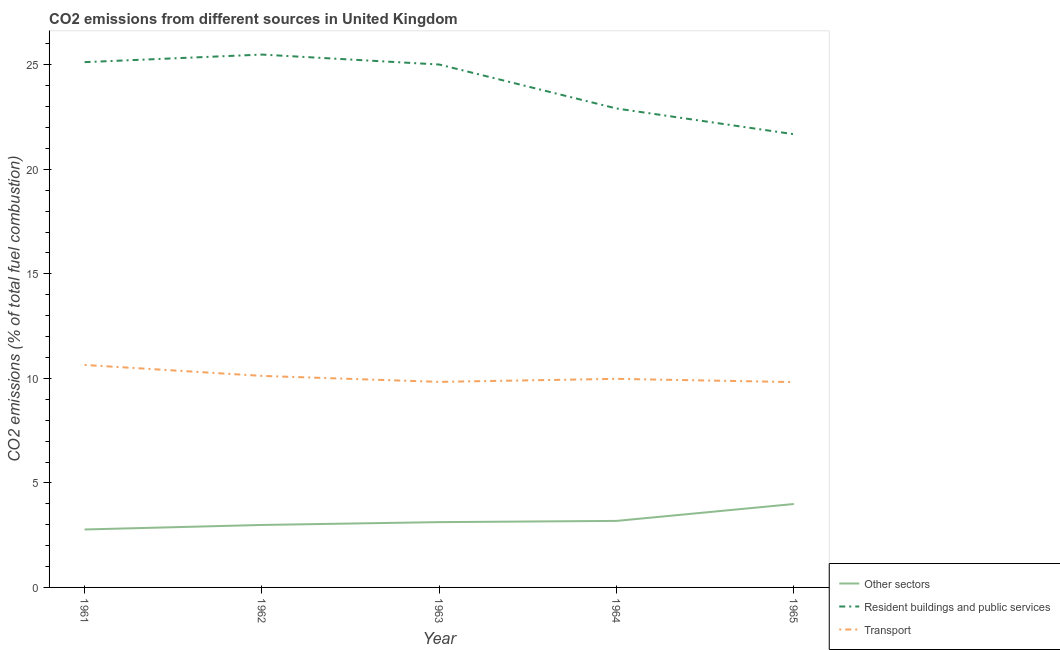How many different coloured lines are there?
Give a very brief answer. 3. Does the line corresponding to percentage of co2 emissions from other sectors intersect with the line corresponding to percentage of co2 emissions from transport?
Your answer should be compact. No. What is the percentage of co2 emissions from transport in 1961?
Make the answer very short. 10.64. Across all years, what is the maximum percentage of co2 emissions from transport?
Provide a short and direct response. 10.64. Across all years, what is the minimum percentage of co2 emissions from resident buildings and public services?
Offer a terse response. 21.68. In which year was the percentage of co2 emissions from other sectors minimum?
Ensure brevity in your answer.  1961. What is the total percentage of co2 emissions from other sectors in the graph?
Offer a very short reply. 16.06. What is the difference between the percentage of co2 emissions from resident buildings and public services in 1962 and that in 1963?
Give a very brief answer. 0.48. What is the difference between the percentage of co2 emissions from resident buildings and public services in 1965 and the percentage of co2 emissions from transport in 1961?
Give a very brief answer. 11.04. What is the average percentage of co2 emissions from transport per year?
Ensure brevity in your answer.  10.08. In the year 1963, what is the difference between the percentage of co2 emissions from other sectors and percentage of co2 emissions from resident buildings and public services?
Your response must be concise. -21.89. What is the ratio of the percentage of co2 emissions from resident buildings and public services in 1964 to that in 1965?
Offer a very short reply. 1.06. Is the difference between the percentage of co2 emissions from other sectors in 1961 and 1963 greater than the difference between the percentage of co2 emissions from transport in 1961 and 1963?
Your answer should be compact. No. What is the difference between the highest and the second highest percentage of co2 emissions from resident buildings and public services?
Your answer should be compact. 0.36. What is the difference between the highest and the lowest percentage of co2 emissions from resident buildings and public services?
Your response must be concise. 3.81. Is the sum of the percentage of co2 emissions from resident buildings and public services in 1961 and 1963 greater than the maximum percentage of co2 emissions from transport across all years?
Make the answer very short. Yes. Is it the case that in every year, the sum of the percentage of co2 emissions from other sectors and percentage of co2 emissions from resident buildings and public services is greater than the percentage of co2 emissions from transport?
Ensure brevity in your answer.  Yes. Is the percentage of co2 emissions from other sectors strictly greater than the percentage of co2 emissions from transport over the years?
Keep it short and to the point. No. Is the percentage of co2 emissions from other sectors strictly less than the percentage of co2 emissions from resident buildings and public services over the years?
Your answer should be compact. Yes. How many years are there in the graph?
Your answer should be very brief. 5. What is the difference between two consecutive major ticks on the Y-axis?
Offer a terse response. 5. Are the values on the major ticks of Y-axis written in scientific E-notation?
Offer a terse response. No. What is the title of the graph?
Ensure brevity in your answer.  CO2 emissions from different sources in United Kingdom. What is the label or title of the Y-axis?
Provide a succinct answer. CO2 emissions (% of total fuel combustion). What is the CO2 emissions (% of total fuel combustion) of Other sectors in 1961?
Keep it short and to the point. 2.77. What is the CO2 emissions (% of total fuel combustion) in Resident buildings and public services in 1961?
Give a very brief answer. 25.13. What is the CO2 emissions (% of total fuel combustion) of Transport in 1961?
Your response must be concise. 10.64. What is the CO2 emissions (% of total fuel combustion) in Other sectors in 1962?
Offer a terse response. 2.99. What is the CO2 emissions (% of total fuel combustion) in Resident buildings and public services in 1962?
Provide a succinct answer. 25.49. What is the CO2 emissions (% of total fuel combustion) of Transport in 1962?
Provide a succinct answer. 10.12. What is the CO2 emissions (% of total fuel combustion) in Other sectors in 1963?
Your answer should be very brief. 3.12. What is the CO2 emissions (% of total fuel combustion) of Resident buildings and public services in 1963?
Offer a terse response. 25.01. What is the CO2 emissions (% of total fuel combustion) in Transport in 1963?
Provide a succinct answer. 9.83. What is the CO2 emissions (% of total fuel combustion) of Other sectors in 1964?
Give a very brief answer. 3.18. What is the CO2 emissions (% of total fuel combustion) of Resident buildings and public services in 1964?
Your response must be concise. 22.91. What is the CO2 emissions (% of total fuel combustion) of Transport in 1964?
Give a very brief answer. 9.98. What is the CO2 emissions (% of total fuel combustion) in Other sectors in 1965?
Make the answer very short. 3.99. What is the CO2 emissions (% of total fuel combustion) in Resident buildings and public services in 1965?
Make the answer very short. 21.68. What is the CO2 emissions (% of total fuel combustion) of Transport in 1965?
Give a very brief answer. 9.82. Across all years, what is the maximum CO2 emissions (% of total fuel combustion) in Other sectors?
Offer a terse response. 3.99. Across all years, what is the maximum CO2 emissions (% of total fuel combustion) in Resident buildings and public services?
Ensure brevity in your answer.  25.49. Across all years, what is the maximum CO2 emissions (% of total fuel combustion) in Transport?
Provide a succinct answer. 10.64. Across all years, what is the minimum CO2 emissions (% of total fuel combustion) of Other sectors?
Keep it short and to the point. 2.77. Across all years, what is the minimum CO2 emissions (% of total fuel combustion) of Resident buildings and public services?
Provide a succinct answer. 21.68. Across all years, what is the minimum CO2 emissions (% of total fuel combustion) in Transport?
Provide a succinct answer. 9.82. What is the total CO2 emissions (% of total fuel combustion) of Other sectors in the graph?
Provide a succinct answer. 16.06. What is the total CO2 emissions (% of total fuel combustion) of Resident buildings and public services in the graph?
Offer a very short reply. 120.23. What is the total CO2 emissions (% of total fuel combustion) of Transport in the graph?
Provide a succinct answer. 50.4. What is the difference between the CO2 emissions (% of total fuel combustion) of Other sectors in 1961 and that in 1962?
Offer a terse response. -0.22. What is the difference between the CO2 emissions (% of total fuel combustion) of Resident buildings and public services in 1961 and that in 1962?
Provide a short and direct response. -0.36. What is the difference between the CO2 emissions (% of total fuel combustion) of Transport in 1961 and that in 1962?
Provide a short and direct response. 0.52. What is the difference between the CO2 emissions (% of total fuel combustion) in Other sectors in 1961 and that in 1963?
Provide a succinct answer. -0.35. What is the difference between the CO2 emissions (% of total fuel combustion) in Resident buildings and public services in 1961 and that in 1963?
Make the answer very short. 0.11. What is the difference between the CO2 emissions (% of total fuel combustion) of Transport in 1961 and that in 1963?
Provide a short and direct response. 0.81. What is the difference between the CO2 emissions (% of total fuel combustion) of Other sectors in 1961 and that in 1964?
Your response must be concise. -0.41. What is the difference between the CO2 emissions (% of total fuel combustion) in Resident buildings and public services in 1961 and that in 1964?
Give a very brief answer. 2.22. What is the difference between the CO2 emissions (% of total fuel combustion) in Transport in 1961 and that in 1964?
Make the answer very short. 0.66. What is the difference between the CO2 emissions (% of total fuel combustion) in Other sectors in 1961 and that in 1965?
Provide a short and direct response. -1.22. What is the difference between the CO2 emissions (% of total fuel combustion) of Resident buildings and public services in 1961 and that in 1965?
Offer a terse response. 3.45. What is the difference between the CO2 emissions (% of total fuel combustion) of Transport in 1961 and that in 1965?
Provide a succinct answer. 0.82. What is the difference between the CO2 emissions (% of total fuel combustion) in Other sectors in 1962 and that in 1963?
Offer a very short reply. -0.14. What is the difference between the CO2 emissions (% of total fuel combustion) of Resident buildings and public services in 1962 and that in 1963?
Your answer should be very brief. 0.48. What is the difference between the CO2 emissions (% of total fuel combustion) in Transport in 1962 and that in 1963?
Give a very brief answer. 0.29. What is the difference between the CO2 emissions (% of total fuel combustion) in Other sectors in 1962 and that in 1964?
Provide a succinct answer. -0.19. What is the difference between the CO2 emissions (% of total fuel combustion) of Resident buildings and public services in 1962 and that in 1964?
Offer a very short reply. 2.58. What is the difference between the CO2 emissions (% of total fuel combustion) of Transport in 1962 and that in 1964?
Your answer should be compact. 0.14. What is the difference between the CO2 emissions (% of total fuel combustion) in Other sectors in 1962 and that in 1965?
Ensure brevity in your answer.  -1. What is the difference between the CO2 emissions (% of total fuel combustion) of Resident buildings and public services in 1962 and that in 1965?
Provide a short and direct response. 3.81. What is the difference between the CO2 emissions (% of total fuel combustion) in Transport in 1962 and that in 1965?
Provide a short and direct response. 0.3. What is the difference between the CO2 emissions (% of total fuel combustion) of Other sectors in 1963 and that in 1964?
Give a very brief answer. -0.06. What is the difference between the CO2 emissions (% of total fuel combustion) of Resident buildings and public services in 1963 and that in 1964?
Offer a very short reply. 2.1. What is the difference between the CO2 emissions (% of total fuel combustion) of Transport in 1963 and that in 1964?
Give a very brief answer. -0.15. What is the difference between the CO2 emissions (% of total fuel combustion) of Other sectors in 1963 and that in 1965?
Offer a very short reply. -0.87. What is the difference between the CO2 emissions (% of total fuel combustion) in Resident buildings and public services in 1963 and that in 1965?
Keep it short and to the point. 3.33. What is the difference between the CO2 emissions (% of total fuel combustion) of Transport in 1963 and that in 1965?
Offer a very short reply. 0.01. What is the difference between the CO2 emissions (% of total fuel combustion) in Other sectors in 1964 and that in 1965?
Your response must be concise. -0.81. What is the difference between the CO2 emissions (% of total fuel combustion) of Resident buildings and public services in 1964 and that in 1965?
Provide a short and direct response. 1.23. What is the difference between the CO2 emissions (% of total fuel combustion) of Transport in 1964 and that in 1965?
Provide a succinct answer. 0.16. What is the difference between the CO2 emissions (% of total fuel combustion) of Other sectors in 1961 and the CO2 emissions (% of total fuel combustion) of Resident buildings and public services in 1962?
Your answer should be very brief. -22.72. What is the difference between the CO2 emissions (% of total fuel combustion) in Other sectors in 1961 and the CO2 emissions (% of total fuel combustion) in Transport in 1962?
Your response must be concise. -7.35. What is the difference between the CO2 emissions (% of total fuel combustion) of Resident buildings and public services in 1961 and the CO2 emissions (% of total fuel combustion) of Transport in 1962?
Make the answer very short. 15.01. What is the difference between the CO2 emissions (% of total fuel combustion) of Other sectors in 1961 and the CO2 emissions (% of total fuel combustion) of Resident buildings and public services in 1963?
Your response must be concise. -22.24. What is the difference between the CO2 emissions (% of total fuel combustion) in Other sectors in 1961 and the CO2 emissions (% of total fuel combustion) in Transport in 1963?
Make the answer very short. -7.06. What is the difference between the CO2 emissions (% of total fuel combustion) in Resident buildings and public services in 1961 and the CO2 emissions (% of total fuel combustion) in Transport in 1963?
Your response must be concise. 15.3. What is the difference between the CO2 emissions (% of total fuel combustion) of Other sectors in 1961 and the CO2 emissions (% of total fuel combustion) of Resident buildings and public services in 1964?
Your response must be concise. -20.14. What is the difference between the CO2 emissions (% of total fuel combustion) in Other sectors in 1961 and the CO2 emissions (% of total fuel combustion) in Transport in 1964?
Offer a terse response. -7.21. What is the difference between the CO2 emissions (% of total fuel combustion) of Resident buildings and public services in 1961 and the CO2 emissions (% of total fuel combustion) of Transport in 1964?
Give a very brief answer. 15.15. What is the difference between the CO2 emissions (% of total fuel combustion) of Other sectors in 1961 and the CO2 emissions (% of total fuel combustion) of Resident buildings and public services in 1965?
Give a very brief answer. -18.91. What is the difference between the CO2 emissions (% of total fuel combustion) of Other sectors in 1961 and the CO2 emissions (% of total fuel combustion) of Transport in 1965?
Your answer should be compact. -7.05. What is the difference between the CO2 emissions (% of total fuel combustion) in Resident buildings and public services in 1961 and the CO2 emissions (% of total fuel combustion) in Transport in 1965?
Give a very brief answer. 15.31. What is the difference between the CO2 emissions (% of total fuel combustion) of Other sectors in 1962 and the CO2 emissions (% of total fuel combustion) of Resident buildings and public services in 1963?
Make the answer very short. -22.03. What is the difference between the CO2 emissions (% of total fuel combustion) in Other sectors in 1962 and the CO2 emissions (% of total fuel combustion) in Transport in 1963?
Your answer should be very brief. -6.84. What is the difference between the CO2 emissions (% of total fuel combustion) in Resident buildings and public services in 1962 and the CO2 emissions (% of total fuel combustion) in Transport in 1963?
Keep it short and to the point. 15.66. What is the difference between the CO2 emissions (% of total fuel combustion) in Other sectors in 1962 and the CO2 emissions (% of total fuel combustion) in Resident buildings and public services in 1964?
Provide a short and direct response. -19.92. What is the difference between the CO2 emissions (% of total fuel combustion) in Other sectors in 1962 and the CO2 emissions (% of total fuel combustion) in Transport in 1964?
Your answer should be compact. -6.99. What is the difference between the CO2 emissions (% of total fuel combustion) of Resident buildings and public services in 1962 and the CO2 emissions (% of total fuel combustion) of Transport in 1964?
Keep it short and to the point. 15.51. What is the difference between the CO2 emissions (% of total fuel combustion) of Other sectors in 1962 and the CO2 emissions (% of total fuel combustion) of Resident buildings and public services in 1965?
Ensure brevity in your answer.  -18.69. What is the difference between the CO2 emissions (% of total fuel combustion) of Other sectors in 1962 and the CO2 emissions (% of total fuel combustion) of Transport in 1965?
Give a very brief answer. -6.83. What is the difference between the CO2 emissions (% of total fuel combustion) in Resident buildings and public services in 1962 and the CO2 emissions (% of total fuel combustion) in Transport in 1965?
Your answer should be very brief. 15.67. What is the difference between the CO2 emissions (% of total fuel combustion) of Other sectors in 1963 and the CO2 emissions (% of total fuel combustion) of Resident buildings and public services in 1964?
Provide a succinct answer. -19.79. What is the difference between the CO2 emissions (% of total fuel combustion) in Other sectors in 1963 and the CO2 emissions (% of total fuel combustion) in Transport in 1964?
Give a very brief answer. -6.85. What is the difference between the CO2 emissions (% of total fuel combustion) in Resident buildings and public services in 1963 and the CO2 emissions (% of total fuel combustion) in Transport in 1964?
Keep it short and to the point. 15.04. What is the difference between the CO2 emissions (% of total fuel combustion) in Other sectors in 1963 and the CO2 emissions (% of total fuel combustion) in Resident buildings and public services in 1965?
Ensure brevity in your answer.  -18.56. What is the difference between the CO2 emissions (% of total fuel combustion) in Other sectors in 1963 and the CO2 emissions (% of total fuel combustion) in Transport in 1965?
Provide a succinct answer. -6.7. What is the difference between the CO2 emissions (% of total fuel combustion) in Resident buildings and public services in 1963 and the CO2 emissions (% of total fuel combustion) in Transport in 1965?
Keep it short and to the point. 15.19. What is the difference between the CO2 emissions (% of total fuel combustion) in Other sectors in 1964 and the CO2 emissions (% of total fuel combustion) in Resident buildings and public services in 1965?
Your response must be concise. -18.5. What is the difference between the CO2 emissions (% of total fuel combustion) in Other sectors in 1964 and the CO2 emissions (% of total fuel combustion) in Transport in 1965?
Your answer should be compact. -6.64. What is the difference between the CO2 emissions (% of total fuel combustion) of Resident buildings and public services in 1964 and the CO2 emissions (% of total fuel combustion) of Transport in 1965?
Ensure brevity in your answer.  13.09. What is the average CO2 emissions (% of total fuel combustion) of Other sectors per year?
Keep it short and to the point. 3.21. What is the average CO2 emissions (% of total fuel combustion) of Resident buildings and public services per year?
Your answer should be very brief. 24.05. What is the average CO2 emissions (% of total fuel combustion) of Transport per year?
Your response must be concise. 10.08. In the year 1961, what is the difference between the CO2 emissions (% of total fuel combustion) of Other sectors and CO2 emissions (% of total fuel combustion) of Resident buildings and public services?
Provide a succinct answer. -22.36. In the year 1961, what is the difference between the CO2 emissions (% of total fuel combustion) in Other sectors and CO2 emissions (% of total fuel combustion) in Transport?
Offer a very short reply. -7.87. In the year 1961, what is the difference between the CO2 emissions (% of total fuel combustion) of Resident buildings and public services and CO2 emissions (% of total fuel combustion) of Transport?
Give a very brief answer. 14.49. In the year 1962, what is the difference between the CO2 emissions (% of total fuel combustion) of Other sectors and CO2 emissions (% of total fuel combustion) of Resident buildings and public services?
Keep it short and to the point. -22.5. In the year 1962, what is the difference between the CO2 emissions (% of total fuel combustion) in Other sectors and CO2 emissions (% of total fuel combustion) in Transport?
Make the answer very short. -7.13. In the year 1962, what is the difference between the CO2 emissions (% of total fuel combustion) of Resident buildings and public services and CO2 emissions (% of total fuel combustion) of Transport?
Offer a terse response. 15.37. In the year 1963, what is the difference between the CO2 emissions (% of total fuel combustion) in Other sectors and CO2 emissions (% of total fuel combustion) in Resident buildings and public services?
Offer a terse response. -21.89. In the year 1963, what is the difference between the CO2 emissions (% of total fuel combustion) of Other sectors and CO2 emissions (% of total fuel combustion) of Transport?
Ensure brevity in your answer.  -6.71. In the year 1963, what is the difference between the CO2 emissions (% of total fuel combustion) of Resident buildings and public services and CO2 emissions (% of total fuel combustion) of Transport?
Offer a very short reply. 15.18. In the year 1964, what is the difference between the CO2 emissions (% of total fuel combustion) of Other sectors and CO2 emissions (% of total fuel combustion) of Resident buildings and public services?
Make the answer very short. -19.73. In the year 1964, what is the difference between the CO2 emissions (% of total fuel combustion) in Other sectors and CO2 emissions (% of total fuel combustion) in Transport?
Offer a terse response. -6.8. In the year 1964, what is the difference between the CO2 emissions (% of total fuel combustion) in Resident buildings and public services and CO2 emissions (% of total fuel combustion) in Transport?
Your response must be concise. 12.93. In the year 1965, what is the difference between the CO2 emissions (% of total fuel combustion) of Other sectors and CO2 emissions (% of total fuel combustion) of Resident buildings and public services?
Keep it short and to the point. -17.69. In the year 1965, what is the difference between the CO2 emissions (% of total fuel combustion) of Other sectors and CO2 emissions (% of total fuel combustion) of Transport?
Your response must be concise. -5.83. In the year 1965, what is the difference between the CO2 emissions (% of total fuel combustion) in Resident buildings and public services and CO2 emissions (% of total fuel combustion) in Transport?
Your response must be concise. 11.86. What is the ratio of the CO2 emissions (% of total fuel combustion) of Other sectors in 1961 to that in 1962?
Provide a succinct answer. 0.93. What is the ratio of the CO2 emissions (% of total fuel combustion) in Resident buildings and public services in 1961 to that in 1962?
Offer a very short reply. 0.99. What is the ratio of the CO2 emissions (% of total fuel combustion) in Transport in 1961 to that in 1962?
Give a very brief answer. 1.05. What is the ratio of the CO2 emissions (% of total fuel combustion) of Other sectors in 1961 to that in 1963?
Your answer should be compact. 0.89. What is the ratio of the CO2 emissions (% of total fuel combustion) in Transport in 1961 to that in 1963?
Keep it short and to the point. 1.08. What is the ratio of the CO2 emissions (% of total fuel combustion) in Other sectors in 1961 to that in 1964?
Provide a short and direct response. 0.87. What is the ratio of the CO2 emissions (% of total fuel combustion) of Resident buildings and public services in 1961 to that in 1964?
Ensure brevity in your answer.  1.1. What is the ratio of the CO2 emissions (% of total fuel combustion) in Transport in 1961 to that in 1964?
Give a very brief answer. 1.07. What is the ratio of the CO2 emissions (% of total fuel combustion) of Other sectors in 1961 to that in 1965?
Your response must be concise. 0.69. What is the ratio of the CO2 emissions (% of total fuel combustion) of Resident buildings and public services in 1961 to that in 1965?
Keep it short and to the point. 1.16. What is the ratio of the CO2 emissions (% of total fuel combustion) of Transport in 1961 to that in 1965?
Provide a short and direct response. 1.08. What is the ratio of the CO2 emissions (% of total fuel combustion) in Other sectors in 1962 to that in 1963?
Your response must be concise. 0.96. What is the ratio of the CO2 emissions (% of total fuel combustion) of Transport in 1962 to that in 1963?
Your answer should be compact. 1.03. What is the ratio of the CO2 emissions (% of total fuel combustion) of Other sectors in 1962 to that in 1964?
Your response must be concise. 0.94. What is the ratio of the CO2 emissions (% of total fuel combustion) in Resident buildings and public services in 1962 to that in 1964?
Keep it short and to the point. 1.11. What is the ratio of the CO2 emissions (% of total fuel combustion) of Transport in 1962 to that in 1964?
Offer a terse response. 1.01. What is the ratio of the CO2 emissions (% of total fuel combustion) in Other sectors in 1962 to that in 1965?
Your answer should be very brief. 0.75. What is the ratio of the CO2 emissions (% of total fuel combustion) of Resident buildings and public services in 1962 to that in 1965?
Keep it short and to the point. 1.18. What is the ratio of the CO2 emissions (% of total fuel combustion) of Transport in 1962 to that in 1965?
Offer a very short reply. 1.03. What is the ratio of the CO2 emissions (% of total fuel combustion) in Other sectors in 1963 to that in 1964?
Your response must be concise. 0.98. What is the ratio of the CO2 emissions (% of total fuel combustion) of Resident buildings and public services in 1963 to that in 1964?
Offer a terse response. 1.09. What is the ratio of the CO2 emissions (% of total fuel combustion) in Transport in 1963 to that in 1964?
Provide a short and direct response. 0.99. What is the ratio of the CO2 emissions (% of total fuel combustion) of Other sectors in 1963 to that in 1965?
Provide a succinct answer. 0.78. What is the ratio of the CO2 emissions (% of total fuel combustion) of Resident buildings and public services in 1963 to that in 1965?
Your answer should be very brief. 1.15. What is the ratio of the CO2 emissions (% of total fuel combustion) of Transport in 1963 to that in 1965?
Your answer should be compact. 1. What is the ratio of the CO2 emissions (% of total fuel combustion) of Other sectors in 1964 to that in 1965?
Offer a terse response. 0.8. What is the ratio of the CO2 emissions (% of total fuel combustion) in Resident buildings and public services in 1964 to that in 1965?
Offer a very short reply. 1.06. What is the ratio of the CO2 emissions (% of total fuel combustion) in Transport in 1964 to that in 1965?
Keep it short and to the point. 1.02. What is the difference between the highest and the second highest CO2 emissions (% of total fuel combustion) in Other sectors?
Offer a very short reply. 0.81. What is the difference between the highest and the second highest CO2 emissions (% of total fuel combustion) in Resident buildings and public services?
Keep it short and to the point. 0.36. What is the difference between the highest and the second highest CO2 emissions (% of total fuel combustion) in Transport?
Make the answer very short. 0.52. What is the difference between the highest and the lowest CO2 emissions (% of total fuel combustion) in Other sectors?
Provide a short and direct response. 1.22. What is the difference between the highest and the lowest CO2 emissions (% of total fuel combustion) of Resident buildings and public services?
Provide a short and direct response. 3.81. What is the difference between the highest and the lowest CO2 emissions (% of total fuel combustion) of Transport?
Offer a very short reply. 0.82. 